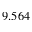<formula> <loc_0><loc_0><loc_500><loc_500>9 . 5 6 4</formula> 